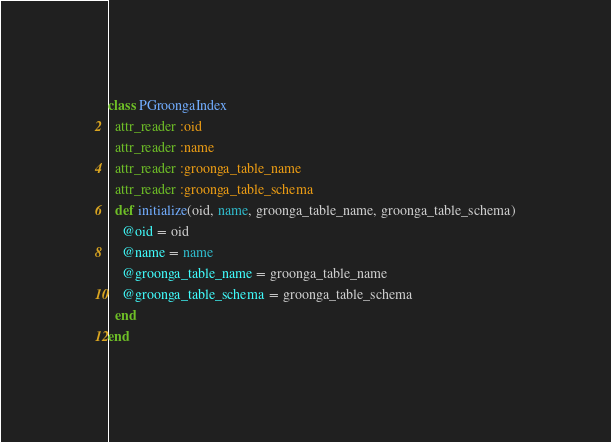Convert code to text. <code><loc_0><loc_0><loc_500><loc_500><_Ruby_>class PGroongaIndex
  attr_reader :oid
  attr_reader :name
  attr_reader :groonga_table_name
  attr_reader :groonga_table_schema
  def initialize(oid, name, groonga_table_name, groonga_table_schema)
    @oid = oid
    @name = name
    @groonga_table_name = groonga_table_name
    @groonga_table_schema = groonga_table_schema
  end
end
</code> 